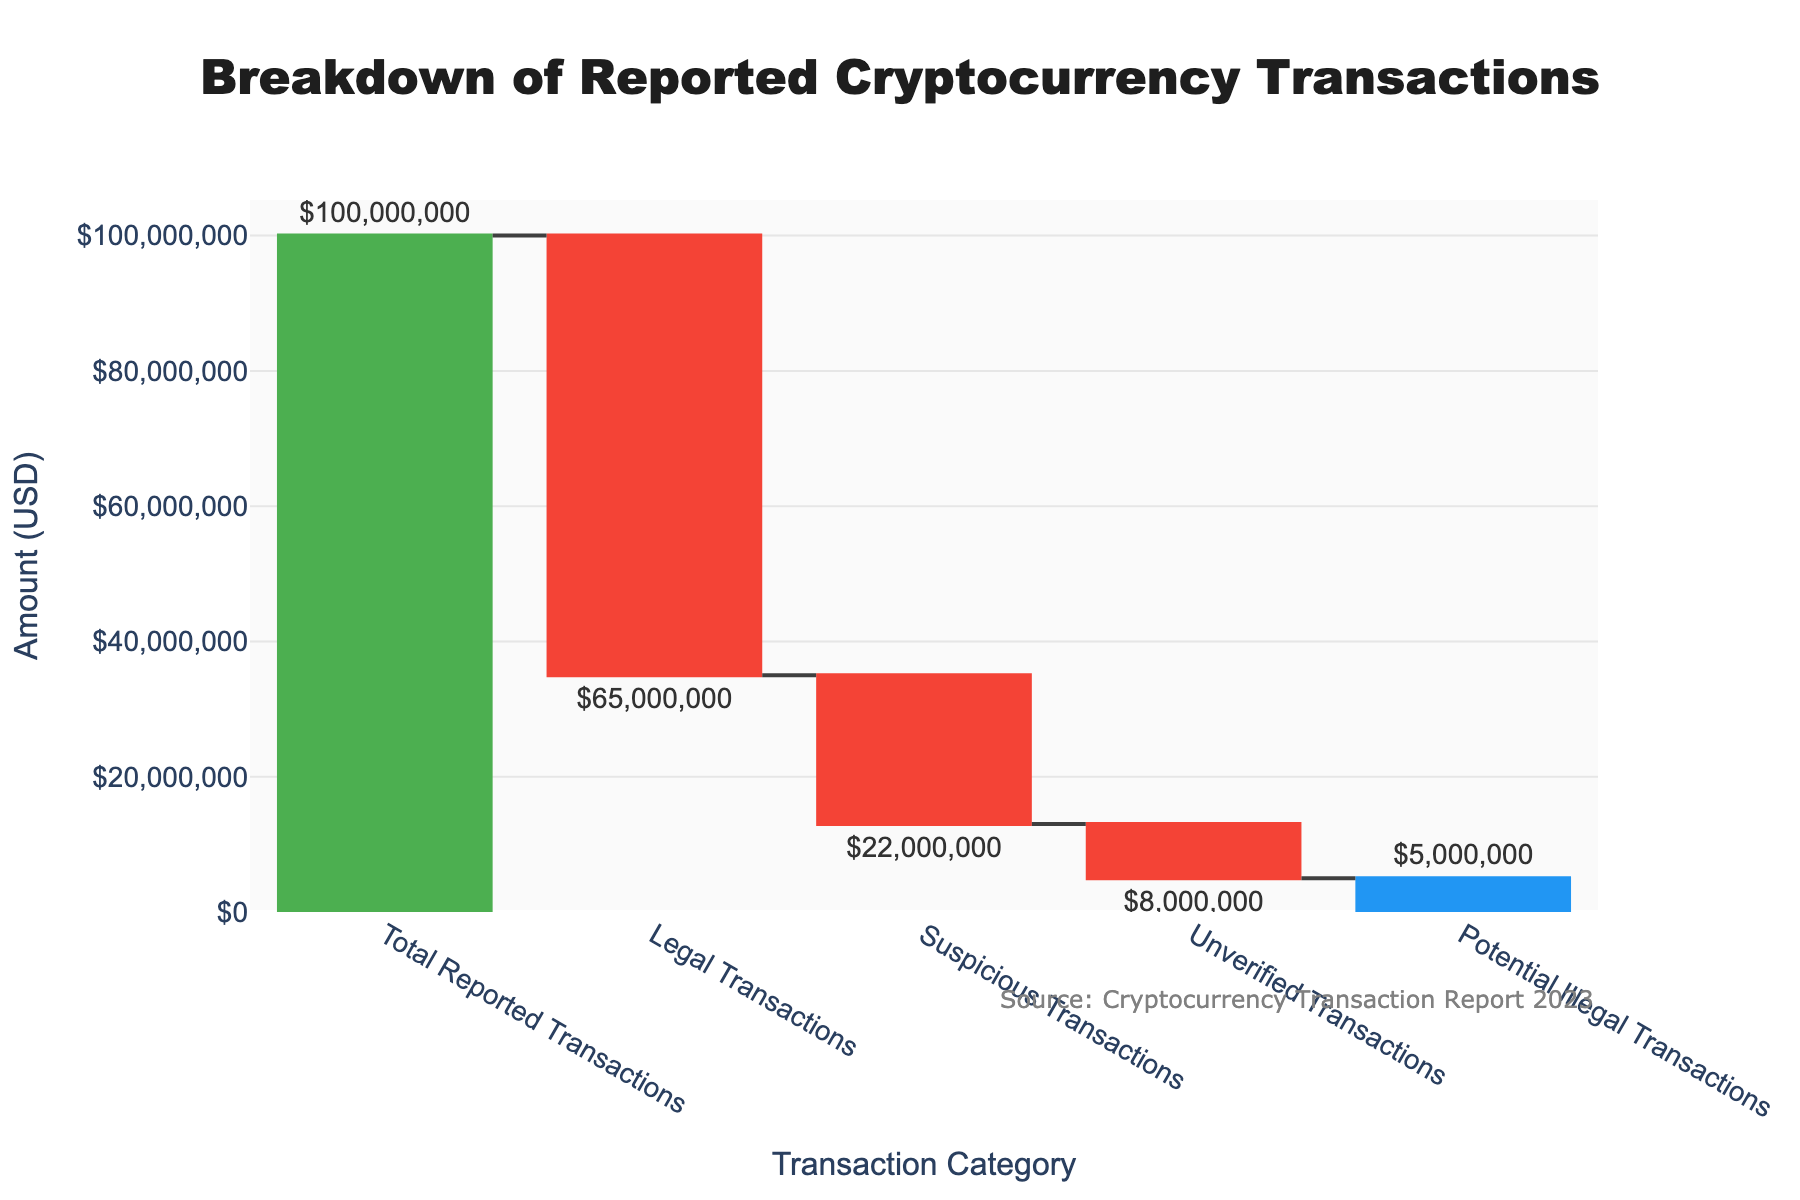What's the total amount of cryptocurrency transactions reported? The title of the chart mentions "Total Reported Transactions," which is the first bar in the waterfall chart. The amount labeled there is $100,000,000.
Answer: $100,000,000 How much of the total reported transactions are categorized as legal? The bar labeled "Legal Transactions" shows a deduction labeled $65,000,000. This means $65,000,000 of the total is considered legal.
Answer: $65,000,000 What is the potential value of illegal transactions? The bar labeled "Potential Illegal Transactions" shows a deduction of $5,000,000, indicating the value of potentially illegal transactions.
Answer: $5,000,000 Compare the amounts of suspicious and unverified transactions. The bar labeled "Suspicious Transactions" shows $22,000,000, and the bar labeled "Unverified Transactions" shows $8,000,000. Comparing these, suspicious transactions have a higher amount.
Answer: Suspicious transactions are higher What is the remaining value after deducting the unverified transactions from the total reported transactions? Starting from the total $100,000,000, subtract $65,000,000 (legal), then $22,000,000 (suspicious), and finally $8,000,000 (unverified). The remaining value is calculated as $100,000,000 - $65,000,000 - $22,000,000 - $8,000,000 = $5,000,000, which matches the "Potential Illegal Transactions".
Answer: $5,000,000 How does the color scheme help in interpreting the chart? Different colors highlight the categories (legal, suspicious, unverified, and potential illegal transactions) and the total. This color differentiation makes it easy to distinguish between the categories and understand their contributions to the total amount.
Answer: Helps distinguish categories What percentage of the total reported transactions are identified as legal transactions? Calculate the percentage: ($65,000,000 / $100,000,000) * 100 = 65%. This means 65% of the total reported transactions are legal transactions.
Answer: 65% Which category comes after the "Total Reported Transactions"? The first category to be deducted after the total reported transactions is "Legal Transactions".
Answer: Legal Transactions How much money remains after considering legal and suspicious transactions but before unverified transactions? Subtract the legal transactions ($65,000,000) and suspicious transactions ($22,000,000) from the total reported transactions ($100,000,000). This gives $100,000,000 - $65,000,000 - $22,000,000 = $13,000,000.
Answer: $13,000,000 Which category contributes the least to the reduction in the total reported transactions? Among the categories, "Potential Illegal Transactions" has the smallest deduction of $5,000,000.
Answer: Potential Illegal Transactions 